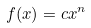<formula> <loc_0><loc_0><loc_500><loc_500>f ( x ) = c x ^ { n }</formula> 